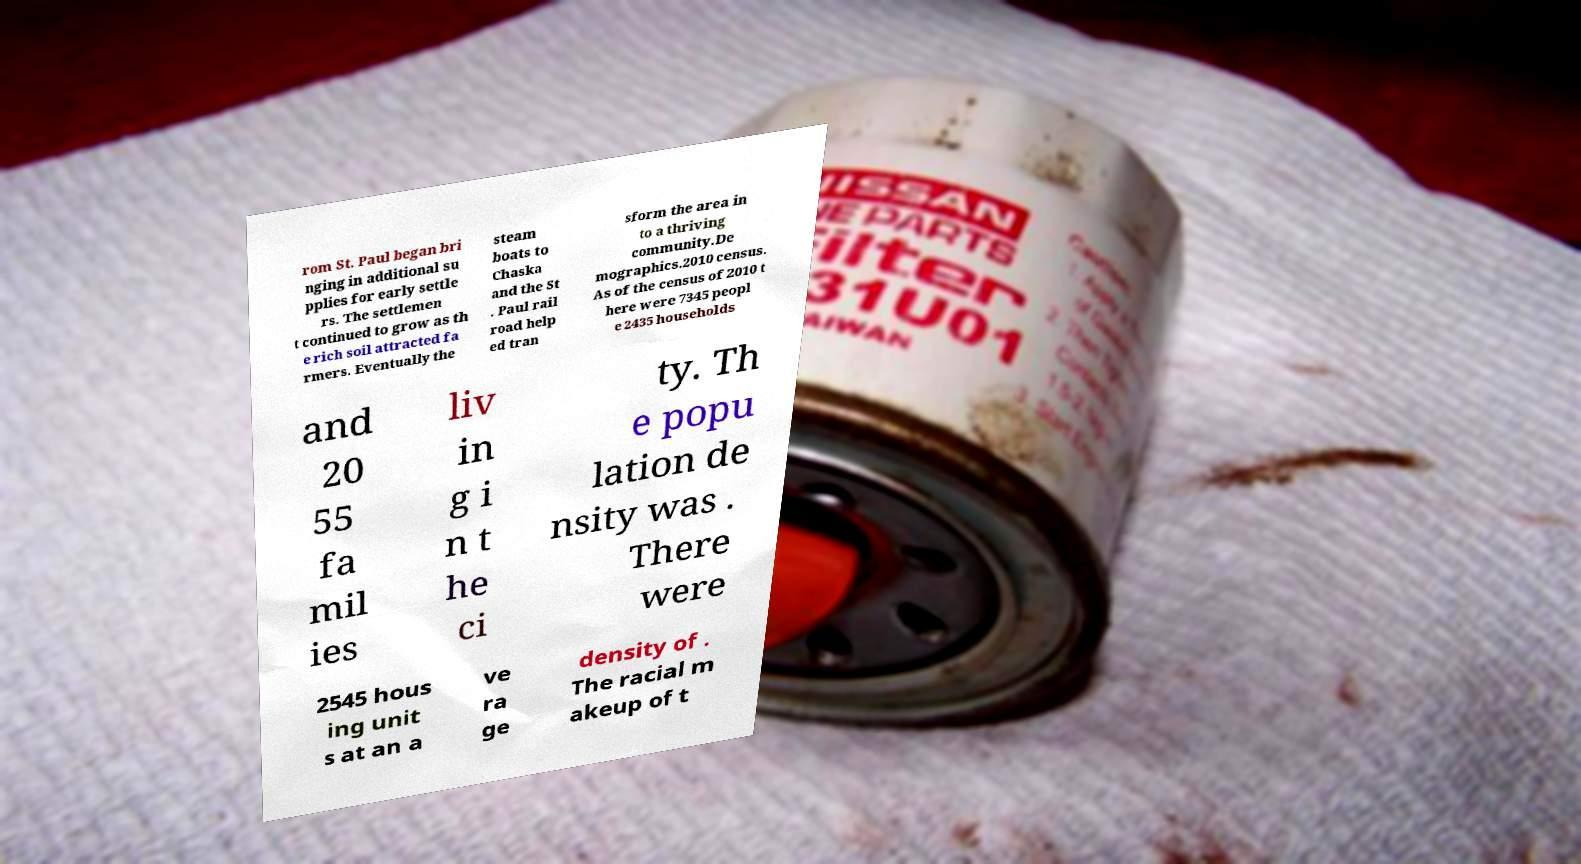I need the written content from this picture converted into text. Can you do that? rom St. Paul began bri nging in additional su pplies for early settle rs. The settlemen t continued to grow as th e rich soil attracted fa rmers. Eventually the steam boats to Chaska and the St . Paul rail road help ed tran sform the area in to a thriving community.De mographics.2010 census. As of the census of 2010 t here were 7345 peopl e 2435 households and 20 55 fa mil ies liv in g i n t he ci ty. Th e popu lation de nsity was . There were 2545 hous ing unit s at an a ve ra ge density of . The racial m akeup of t 